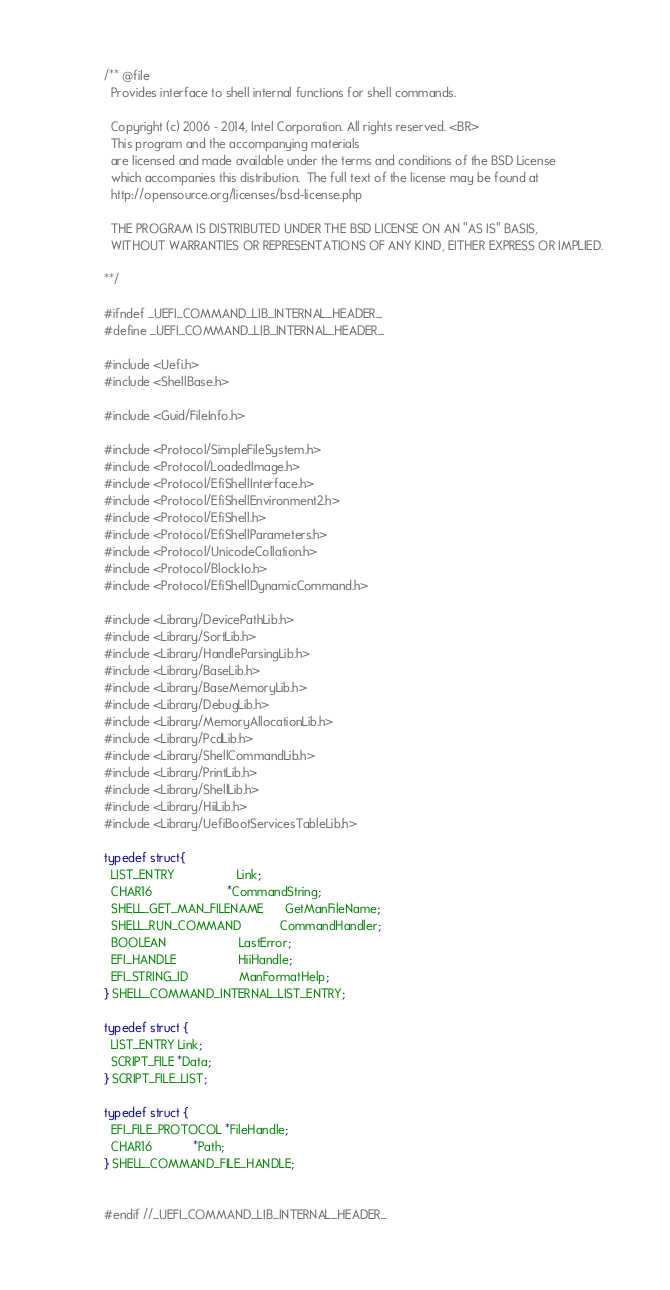<code> <loc_0><loc_0><loc_500><loc_500><_C_>/** @file
  Provides interface to shell internal functions for shell commands.

  Copyright (c) 2006 - 2014, Intel Corporation. All rights reserved. <BR>
  This program and the accompanying materials
  are licensed and made available under the terms and conditions of the BSD License
  which accompanies this distribution.  The full text of the license may be found at
  http://opensource.org/licenses/bsd-license.php

  THE PROGRAM IS DISTRIBUTED UNDER THE BSD LICENSE ON AN "AS IS" BASIS,
  WITHOUT WARRANTIES OR REPRESENTATIONS OF ANY KIND, EITHER EXPRESS OR IMPLIED.

**/

#ifndef _UEFI_COMMAND_LIB_INTERNAL_HEADER_
#define _UEFI_COMMAND_LIB_INTERNAL_HEADER_

#include <Uefi.h>
#include <ShellBase.h>

#include <Guid/FileInfo.h>

#include <Protocol/SimpleFileSystem.h>
#include <Protocol/LoadedImage.h>
#include <Protocol/EfiShellInterface.h>
#include <Protocol/EfiShellEnvironment2.h>
#include <Protocol/EfiShell.h>
#include <Protocol/EfiShellParameters.h>
#include <Protocol/UnicodeCollation.h>
#include <Protocol/BlockIo.h>
#include <Protocol/EfiShellDynamicCommand.h>

#include <Library/DevicePathLib.h>
#include <Library/SortLib.h>
#include <Library/HandleParsingLib.h>
#include <Library/BaseLib.h>
#include <Library/BaseMemoryLib.h>
#include <Library/DebugLib.h>
#include <Library/MemoryAllocationLib.h>
#include <Library/PcdLib.h>
#include <Library/ShellCommandLib.h>
#include <Library/PrintLib.h>
#include <Library/ShellLib.h>
#include <Library/HiiLib.h>
#include <Library/UefiBootServicesTableLib.h>

typedef struct{
  LIST_ENTRY                  Link;
  CHAR16                      *CommandString;
  SHELL_GET_MAN_FILENAME      GetManFileName;
  SHELL_RUN_COMMAND           CommandHandler;
  BOOLEAN                     LastError;
  EFI_HANDLE                  HiiHandle;
  EFI_STRING_ID               ManFormatHelp;
} SHELL_COMMAND_INTERNAL_LIST_ENTRY;

typedef struct {
  LIST_ENTRY Link;
  SCRIPT_FILE *Data;
} SCRIPT_FILE_LIST;

typedef struct {
  EFI_FILE_PROTOCOL *FileHandle;
  CHAR16            *Path;
} SHELL_COMMAND_FILE_HANDLE;


#endif //_UEFI_COMMAND_LIB_INTERNAL_HEADER_

</code> 